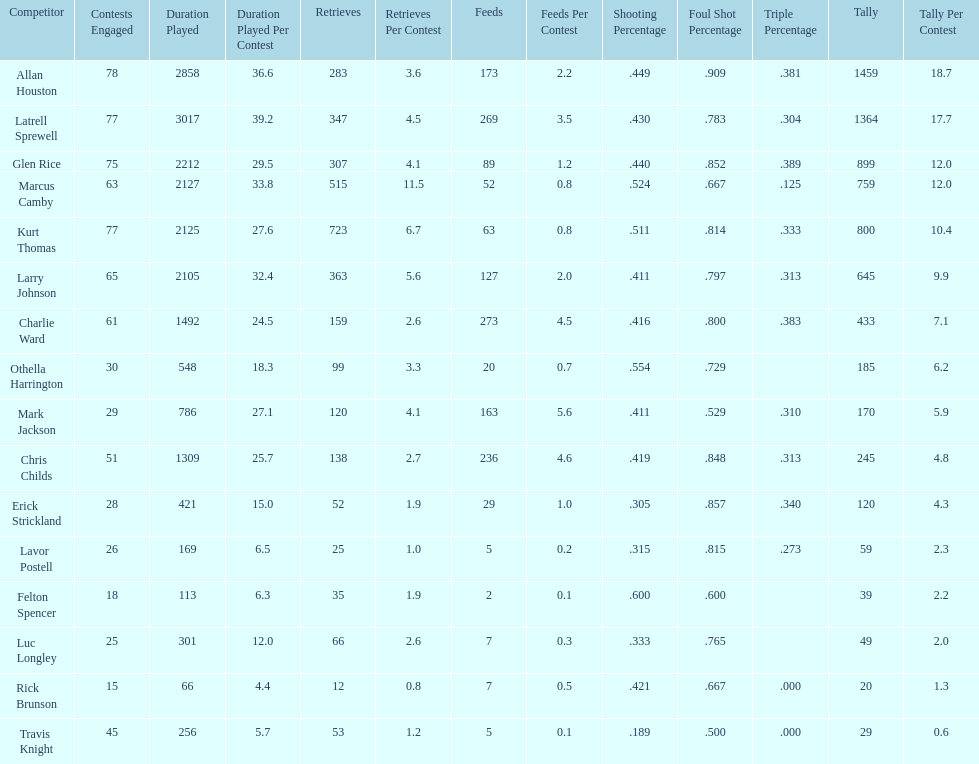Did kurt thomas play more or less than 2126 minutes? Less. 